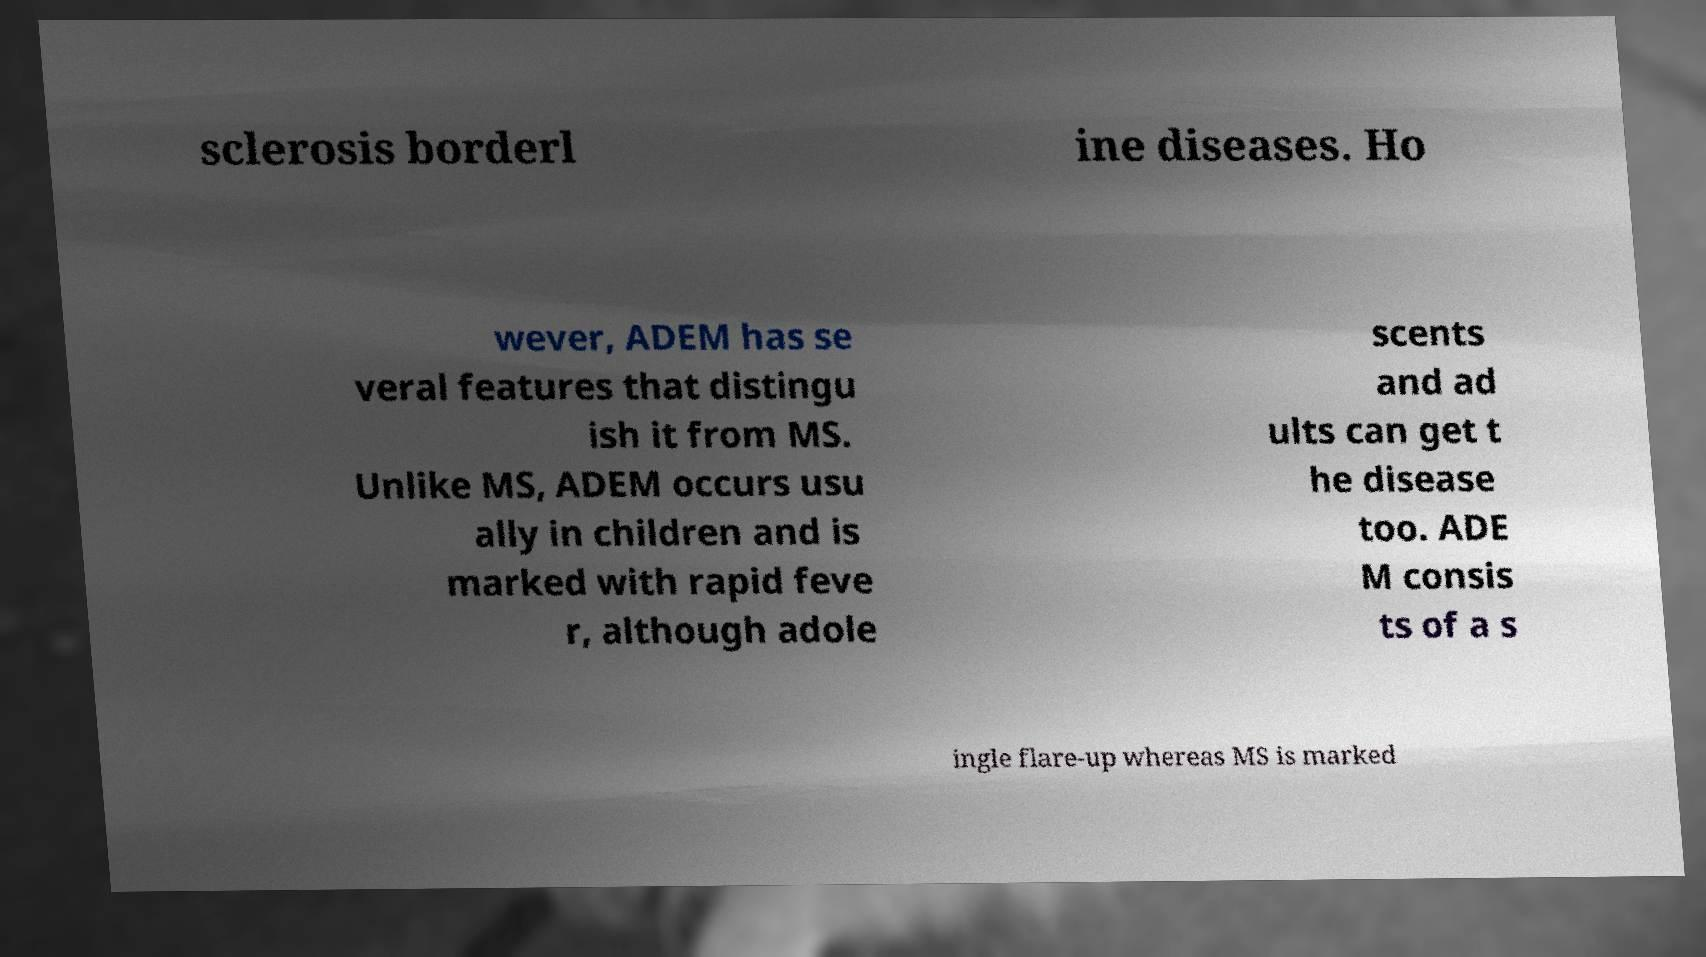Can you accurately transcribe the text from the provided image for me? sclerosis borderl ine diseases. Ho wever, ADEM has se veral features that distingu ish it from MS. Unlike MS, ADEM occurs usu ally in children and is marked with rapid feve r, although adole scents and ad ults can get t he disease too. ADE M consis ts of a s ingle flare-up whereas MS is marked 